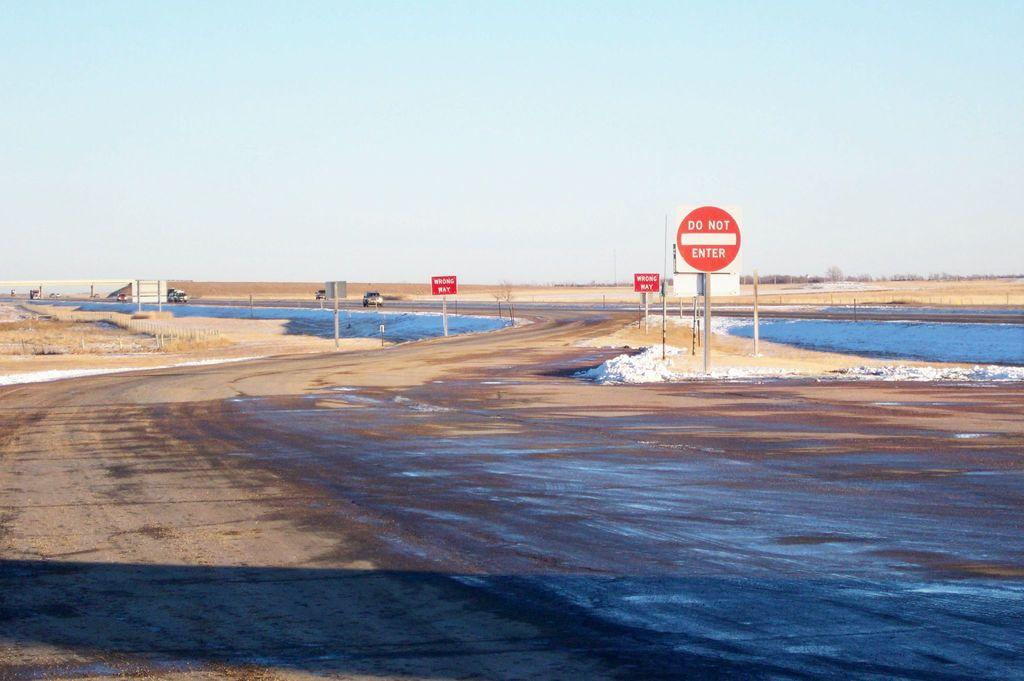<image>
Give a short and clear explanation of the subsequent image. A road next to a highway with signs saying Do Not Enter. 